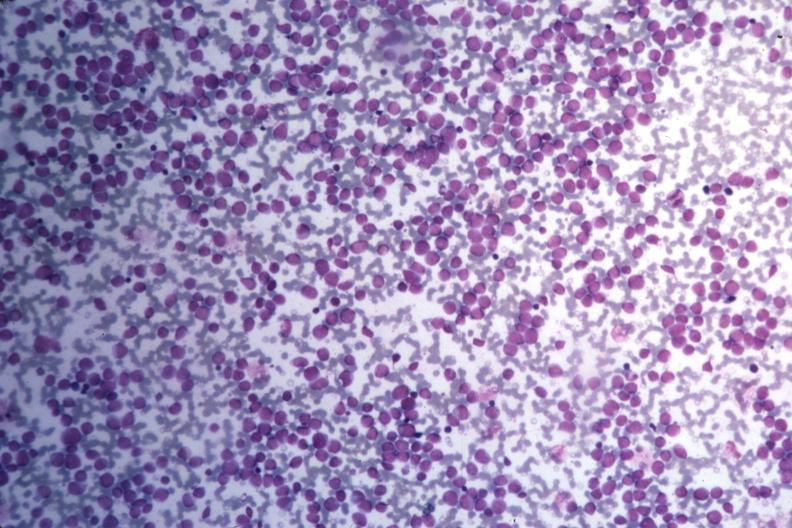what do wrights stain?
Answer the question using a single word or phrase. Many pleomorphic blast cells readily seen 